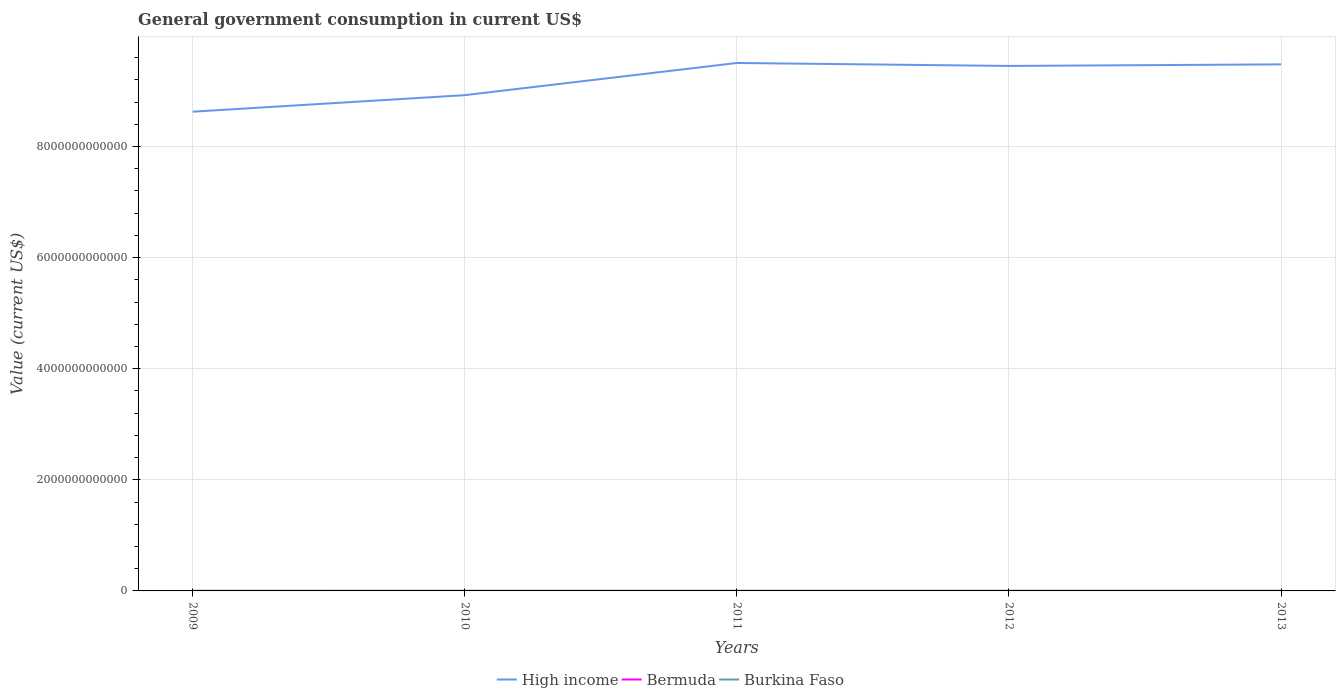How many different coloured lines are there?
Keep it short and to the point. 3. Across all years, what is the maximum government conusmption in Bermuda?
Provide a short and direct response. 8.37e+08. In which year was the government conusmption in High income maximum?
Make the answer very short. 2009. What is the total government conusmption in Bermuda in the graph?
Make the answer very short. -4.34e+07. What is the difference between the highest and the second highest government conusmption in High income?
Provide a succinct answer. 8.77e+11. What is the difference between the highest and the lowest government conusmption in Bermuda?
Give a very brief answer. 3. Is the government conusmption in Bermuda strictly greater than the government conusmption in Burkina Faso over the years?
Provide a short and direct response. Yes. What is the difference between two consecutive major ticks on the Y-axis?
Offer a terse response. 2.00e+12. Does the graph contain grids?
Offer a very short reply. Yes. Where does the legend appear in the graph?
Keep it short and to the point. Bottom center. How many legend labels are there?
Provide a short and direct response. 3. How are the legend labels stacked?
Give a very brief answer. Horizontal. What is the title of the graph?
Your answer should be very brief. General government consumption in current US$. What is the label or title of the X-axis?
Provide a succinct answer. Years. What is the label or title of the Y-axis?
Provide a succinct answer. Value (current US$). What is the Value (current US$) in High income in 2009?
Offer a very short reply. 8.63e+12. What is the Value (current US$) of Bermuda in 2009?
Offer a very short reply. 8.47e+08. What is the Value (current US$) of Burkina Faso in 2009?
Offer a very short reply. 1.81e+09. What is the Value (current US$) in High income in 2010?
Ensure brevity in your answer.  8.92e+12. What is the Value (current US$) of Bermuda in 2010?
Ensure brevity in your answer.  8.90e+08. What is the Value (current US$) in Burkina Faso in 2010?
Provide a succinct answer. 1.85e+09. What is the Value (current US$) of High income in 2011?
Your response must be concise. 9.50e+12. What is the Value (current US$) of Bermuda in 2011?
Make the answer very short. 8.90e+08. What is the Value (current US$) of Burkina Faso in 2011?
Ensure brevity in your answer.  2.21e+09. What is the Value (current US$) in High income in 2012?
Keep it short and to the point. 9.45e+12. What is the Value (current US$) in Bermuda in 2012?
Provide a succinct answer. 8.81e+08. What is the Value (current US$) of Burkina Faso in 2012?
Provide a succinct answer. 2.33e+09. What is the Value (current US$) of High income in 2013?
Offer a terse response. 9.48e+12. What is the Value (current US$) in Bermuda in 2013?
Provide a succinct answer. 8.37e+08. What is the Value (current US$) of Burkina Faso in 2013?
Provide a succinct answer. 2.51e+09. Across all years, what is the maximum Value (current US$) in High income?
Ensure brevity in your answer.  9.50e+12. Across all years, what is the maximum Value (current US$) of Bermuda?
Give a very brief answer. 8.90e+08. Across all years, what is the maximum Value (current US$) in Burkina Faso?
Ensure brevity in your answer.  2.51e+09. Across all years, what is the minimum Value (current US$) of High income?
Your answer should be very brief. 8.63e+12. Across all years, what is the minimum Value (current US$) in Bermuda?
Your answer should be very brief. 8.37e+08. Across all years, what is the minimum Value (current US$) of Burkina Faso?
Provide a succinct answer. 1.81e+09. What is the total Value (current US$) of High income in the graph?
Keep it short and to the point. 4.60e+13. What is the total Value (current US$) in Bermuda in the graph?
Your answer should be very brief. 4.34e+09. What is the total Value (current US$) of Burkina Faso in the graph?
Offer a terse response. 1.07e+1. What is the difference between the Value (current US$) of High income in 2009 and that in 2010?
Offer a very short reply. -2.98e+11. What is the difference between the Value (current US$) of Bermuda in 2009 and that in 2010?
Provide a short and direct response. -4.34e+07. What is the difference between the Value (current US$) in Burkina Faso in 2009 and that in 2010?
Make the answer very short. -4.30e+07. What is the difference between the Value (current US$) in High income in 2009 and that in 2011?
Make the answer very short. -8.77e+11. What is the difference between the Value (current US$) in Bermuda in 2009 and that in 2011?
Keep it short and to the point. -4.26e+07. What is the difference between the Value (current US$) of Burkina Faso in 2009 and that in 2011?
Offer a very short reply. -3.95e+08. What is the difference between the Value (current US$) in High income in 2009 and that in 2012?
Offer a very short reply. -8.23e+11. What is the difference between the Value (current US$) in Bermuda in 2009 and that in 2012?
Ensure brevity in your answer.  -3.37e+07. What is the difference between the Value (current US$) in Burkina Faso in 2009 and that in 2012?
Give a very brief answer. -5.17e+08. What is the difference between the Value (current US$) of High income in 2009 and that in 2013?
Ensure brevity in your answer.  -8.52e+11. What is the difference between the Value (current US$) of Bermuda in 2009 and that in 2013?
Make the answer very short. 1.03e+07. What is the difference between the Value (current US$) in Burkina Faso in 2009 and that in 2013?
Provide a succinct answer. -7.03e+08. What is the difference between the Value (current US$) of High income in 2010 and that in 2011?
Provide a succinct answer. -5.79e+11. What is the difference between the Value (current US$) of Bermuda in 2010 and that in 2011?
Make the answer very short. 8.17e+05. What is the difference between the Value (current US$) of Burkina Faso in 2010 and that in 2011?
Provide a short and direct response. -3.52e+08. What is the difference between the Value (current US$) of High income in 2010 and that in 2012?
Offer a terse response. -5.26e+11. What is the difference between the Value (current US$) of Bermuda in 2010 and that in 2012?
Keep it short and to the point. 9.67e+06. What is the difference between the Value (current US$) of Burkina Faso in 2010 and that in 2012?
Ensure brevity in your answer.  -4.74e+08. What is the difference between the Value (current US$) in High income in 2010 and that in 2013?
Your response must be concise. -5.54e+11. What is the difference between the Value (current US$) in Bermuda in 2010 and that in 2013?
Provide a short and direct response. 5.36e+07. What is the difference between the Value (current US$) in Burkina Faso in 2010 and that in 2013?
Make the answer very short. -6.60e+08. What is the difference between the Value (current US$) of High income in 2011 and that in 2012?
Ensure brevity in your answer.  5.35e+1. What is the difference between the Value (current US$) in Bermuda in 2011 and that in 2012?
Give a very brief answer. 8.85e+06. What is the difference between the Value (current US$) of Burkina Faso in 2011 and that in 2012?
Offer a terse response. -1.22e+08. What is the difference between the Value (current US$) of High income in 2011 and that in 2013?
Provide a short and direct response. 2.52e+1. What is the difference between the Value (current US$) in Bermuda in 2011 and that in 2013?
Provide a succinct answer. 5.28e+07. What is the difference between the Value (current US$) of Burkina Faso in 2011 and that in 2013?
Make the answer very short. -3.08e+08. What is the difference between the Value (current US$) in High income in 2012 and that in 2013?
Your response must be concise. -2.83e+1. What is the difference between the Value (current US$) of Bermuda in 2012 and that in 2013?
Give a very brief answer. 4.40e+07. What is the difference between the Value (current US$) in Burkina Faso in 2012 and that in 2013?
Provide a succinct answer. -1.86e+08. What is the difference between the Value (current US$) of High income in 2009 and the Value (current US$) of Bermuda in 2010?
Provide a short and direct response. 8.63e+12. What is the difference between the Value (current US$) of High income in 2009 and the Value (current US$) of Burkina Faso in 2010?
Your response must be concise. 8.62e+12. What is the difference between the Value (current US$) in Bermuda in 2009 and the Value (current US$) in Burkina Faso in 2010?
Offer a terse response. -1.01e+09. What is the difference between the Value (current US$) of High income in 2009 and the Value (current US$) of Bermuda in 2011?
Offer a very short reply. 8.63e+12. What is the difference between the Value (current US$) of High income in 2009 and the Value (current US$) of Burkina Faso in 2011?
Make the answer very short. 8.62e+12. What is the difference between the Value (current US$) in Bermuda in 2009 and the Value (current US$) in Burkina Faso in 2011?
Ensure brevity in your answer.  -1.36e+09. What is the difference between the Value (current US$) of High income in 2009 and the Value (current US$) of Bermuda in 2012?
Offer a very short reply. 8.63e+12. What is the difference between the Value (current US$) of High income in 2009 and the Value (current US$) of Burkina Faso in 2012?
Ensure brevity in your answer.  8.62e+12. What is the difference between the Value (current US$) of Bermuda in 2009 and the Value (current US$) of Burkina Faso in 2012?
Offer a terse response. -1.48e+09. What is the difference between the Value (current US$) in High income in 2009 and the Value (current US$) in Bermuda in 2013?
Give a very brief answer. 8.63e+12. What is the difference between the Value (current US$) in High income in 2009 and the Value (current US$) in Burkina Faso in 2013?
Make the answer very short. 8.62e+12. What is the difference between the Value (current US$) in Bermuda in 2009 and the Value (current US$) in Burkina Faso in 2013?
Make the answer very short. -1.67e+09. What is the difference between the Value (current US$) of High income in 2010 and the Value (current US$) of Bermuda in 2011?
Your response must be concise. 8.92e+12. What is the difference between the Value (current US$) of High income in 2010 and the Value (current US$) of Burkina Faso in 2011?
Provide a succinct answer. 8.92e+12. What is the difference between the Value (current US$) in Bermuda in 2010 and the Value (current US$) in Burkina Faso in 2011?
Offer a very short reply. -1.32e+09. What is the difference between the Value (current US$) of High income in 2010 and the Value (current US$) of Bermuda in 2012?
Offer a terse response. 8.92e+12. What is the difference between the Value (current US$) in High income in 2010 and the Value (current US$) in Burkina Faso in 2012?
Ensure brevity in your answer.  8.92e+12. What is the difference between the Value (current US$) of Bermuda in 2010 and the Value (current US$) of Burkina Faso in 2012?
Ensure brevity in your answer.  -1.44e+09. What is the difference between the Value (current US$) of High income in 2010 and the Value (current US$) of Bermuda in 2013?
Give a very brief answer. 8.92e+12. What is the difference between the Value (current US$) in High income in 2010 and the Value (current US$) in Burkina Faso in 2013?
Offer a very short reply. 8.92e+12. What is the difference between the Value (current US$) of Bermuda in 2010 and the Value (current US$) of Burkina Faso in 2013?
Make the answer very short. -1.62e+09. What is the difference between the Value (current US$) in High income in 2011 and the Value (current US$) in Bermuda in 2012?
Your response must be concise. 9.50e+12. What is the difference between the Value (current US$) of High income in 2011 and the Value (current US$) of Burkina Faso in 2012?
Your response must be concise. 9.50e+12. What is the difference between the Value (current US$) of Bermuda in 2011 and the Value (current US$) of Burkina Faso in 2012?
Your answer should be compact. -1.44e+09. What is the difference between the Value (current US$) of High income in 2011 and the Value (current US$) of Bermuda in 2013?
Provide a succinct answer. 9.50e+12. What is the difference between the Value (current US$) of High income in 2011 and the Value (current US$) of Burkina Faso in 2013?
Give a very brief answer. 9.50e+12. What is the difference between the Value (current US$) of Bermuda in 2011 and the Value (current US$) of Burkina Faso in 2013?
Give a very brief answer. -1.62e+09. What is the difference between the Value (current US$) of High income in 2012 and the Value (current US$) of Bermuda in 2013?
Your answer should be compact. 9.45e+12. What is the difference between the Value (current US$) in High income in 2012 and the Value (current US$) in Burkina Faso in 2013?
Provide a succinct answer. 9.45e+12. What is the difference between the Value (current US$) in Bermuda in 2012 and the Value (current US$) in Burkina Faso in 2013?
Ensure brevity in your answer.  -1.63e+09. What is the average Value (current US$) in High income per year?
Ensure brevity in your answer.  9.20e+12. What is the average Value (current US$) of Bermuda per year?
Your response must be concise. 8.69e+08. What is the average Value (current US$) in Burkina Faso per year?
Make the answer very short. 2.14e+09. In the year 2009, what is the difference between the Value (current US$) of High income and Value (current US$) of Bermuda?
Offer a very short reply. 8.63e+12. In the year 2009, what is the difference between the Value (current US$) in High income and Value (current US$) in Burkina Faso?
Make the answer very short. 8.62e+12. In the year 2009, what is the difference between the Value (current US$) in Bermuda and Value (current US$) in Burkina Faso?
Offer a very short reply. -9.64e+08. In the year 2010, what is the difference between the Value (current US$) of High income and Value (current US$) of Bermuda?
Provide a short and direct response. 8.92e+12. In the year 2010, what is the difference between the Value (current US$) of High income and Value (current US$) of Burkina Faso?
Your response must be concise. 8.92e+12. In the year 2010, what is the difference between the Value (current US$) in Bermuda and Value (current US$) in Burkina Faso?
Provide a succinct answer. -9.63e+08. In the year 2011, what is the difference between the Value (current US$) of High income and Value (current US$) of Bermuda?
Your answer should be compact. 9.50e+12. In the year 2011, what is the difference between the Value (current US$) of High income and Value (current US$) of Burkina Faso?
Your answer should be compact. 9.50e+12. In the year 2011, what is the difference between the Value (current US$) of Bermuda and Value (current US$) of Burkina Faso?
Provide a succinct answer. -1.32e+09. In the year 2012, what is the difference between the Value (current US$) of High income and Value (current US$) of Bermuda?
Make the answer very short. 9.45e+12. In the year 2012, what is the difference between the Value (current US$) of High income and Value (current US$) of Burkina Faso?
Give a very brief answer. 9.45e+12. In the year 2012, what is the difference between the Value (current US$) of Bermuda and Value (current US$) of Burkina Faso?
Offer a terse response. -1.45e+09. In the year 2013, what is the difference between the Value (current US$) in High income and Value (current US$) in Bermuda?
Offer a terse response. 9.48e+12. In the year 2013, what is the difference between the Value (current US$) in High income and Value (current US$) in Burkina Faso?
Give a very brief answer. 9.48e+12. In the year 2013, what is the difference between the Value (current US$) in Bermuda and Value (current US$) in Burkina Faso?
Provide a succinct answer. -1.68e+09. What is the ratio of the Value (current US$) in High income in 2009 to that in 2010?
Offer a very short reply. 0.97. What is the ratio of the Value (current US$) of Bermuda in 2009 to that in 2010?
Provide a short and direct response. 0.95. What is the ratio of the Value (current US$) of Burkina Faso in 2009 to that in 2010?
Keep it short and to the point. 0.98. What is the ratio of the Value (current US$) of High income in 2009 to that in 2011?
Make the answer very short. 0.91. What is the ratio of the Value (current US$) of Bermuda in 2009 to that in 2011?
Your answer should be compact. 0.95. What is the ratio of the Value (current US$) of Burkina Faso in 2009 to that in 2011?
Make the answer very short. 0.82. What is the ratio of the Value (current US$) in High income in 2009 to that in 2012?
Your answer should be very brief. 0.91. What is the ratio of the Value (current US$) in Bermuda in 2009 to that in 2012?
Provide a succinct answer. 0.96. What is the ratio of the Value (current US$) of Burkina Faso in 2009 to that in 2012?
Keep it short and to the point. 0.78. What is the ratio of the Value (current US$) of High income in 2009 to that in 2013?
Give a very brief answer. 0.91. What is the ratio of the Value (current US$) of Bermuda in 2009 to that in 2013?
Make the answer very short. 1.01. What is the ratio of the Value (current US$) of Burkina Faso in 2009 to that in 2013?
Your answer should be very brief. 0.72. What is the ratio of the Value (current US$) of High income in 2010 to that in 2011?
Offer a very short reply. 0.94. What is the ratio of the Value (current US$) of Bermuda in 2010 to that in 2011?
Offer a terse response. 1. What is the ratio of the Value (current US$) of Burkina Faso in 2010 to that in 2011?
Provide a succinct answer. 0.84. What is the ratio of the Value (current US$) in High income in 2010 to that in 2012?
Your answer should be compact. 0.94. What is the ratio of the Value (current US$) in Burkina Faso in 2010 to that in 2012?
Ensure brevity in your answer.  0.8. What is the ratio of the Value (current US$) in High income in 2010 to that in 2013?
Keep it short and to the point. 0.94. What is the ratio of the Value (current US$) of Bermuda in 2010 to that in 2013?
Provide a succinct answer. 1.06. What is the ratio of the Value (current US$) in Burkina Faso in 2010 to that in 2013?
Provide a short and direct response. 0.74. What is the ratio of the Value (current US$) of High income in 2011 to that in 2012?
Give a very brief answer. 1.01. What is the ratio of the Value (current US$) in Bermuda in 2011 to that in 2012?
Make the answer very short. 1.01. What is the ratio of the Value (current US$) in Burkina Faso in 2011 to that in 2012?
Provide a succinct answer. 0.95. What is the ratio of the Value (current US$) of High income in 2011 to that in 2013?
Keep it short and to the point. 1. What is the ratio of the Value (current US$) in Bermuda in 2011 to that in 2013?
Provide a succinct answer. 1.06. What is the ratio of the Value (current US$) in Burkina Faso in 2011 to that in 2013?
Provide a short and direct response. 0.88. What is the ratio of the Value (current US$) of Bermuda in 2012 to that in 2013?
Keep it short and to the point. 1.05. What is the ratio of the Value (current US$) in Burkina Faso in 2012 to that in 2013?
Make the answer very short. 0.93. What is the difference between the highest and the second highest Value (current US$) in High income?
Your answer should be very brief. 2.52e+1. What is the difference between the highest and the second highest Value (current US$) of Bermuda?
Keep it short and to the point. 8.17e+05. What is the difference between the highest and the second highest Value (current US$) of Burkina Faso?
Your response must be concise. 1.86e+08. What is the difference between the highest and the lowest Value (current US$) of High income?
Keep it short and to the point. 8.77e+11. What is the difference between the highest and the lowest Value (current US$) of Bermuda?
Offer a terse response. 5.36e+07. What is the difference between the highest and the lowest Value (current US$) in Burkina Faso?
Provide a succinct answer. 7.03e+08. 